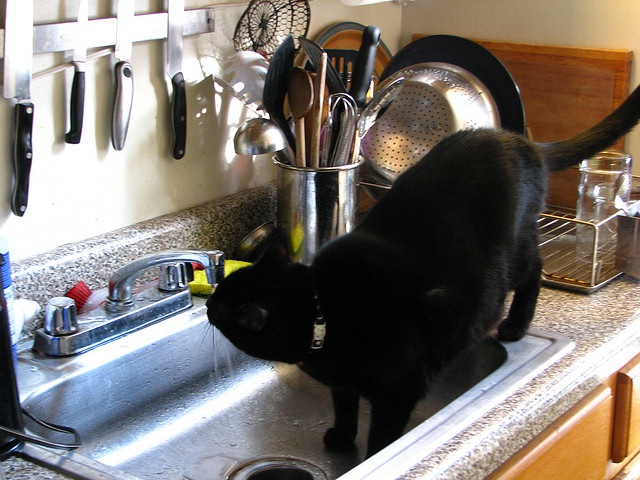Describe the objects in this image and their specific colors. I can see sink in gray, white, darkgray, and black tones, cat in gray and black tones, knife in gray, white, black, and darkgray tones, cup in gray, maroon, and tan tones, and knife in gray, black, white, and darkgray tones in this image. 